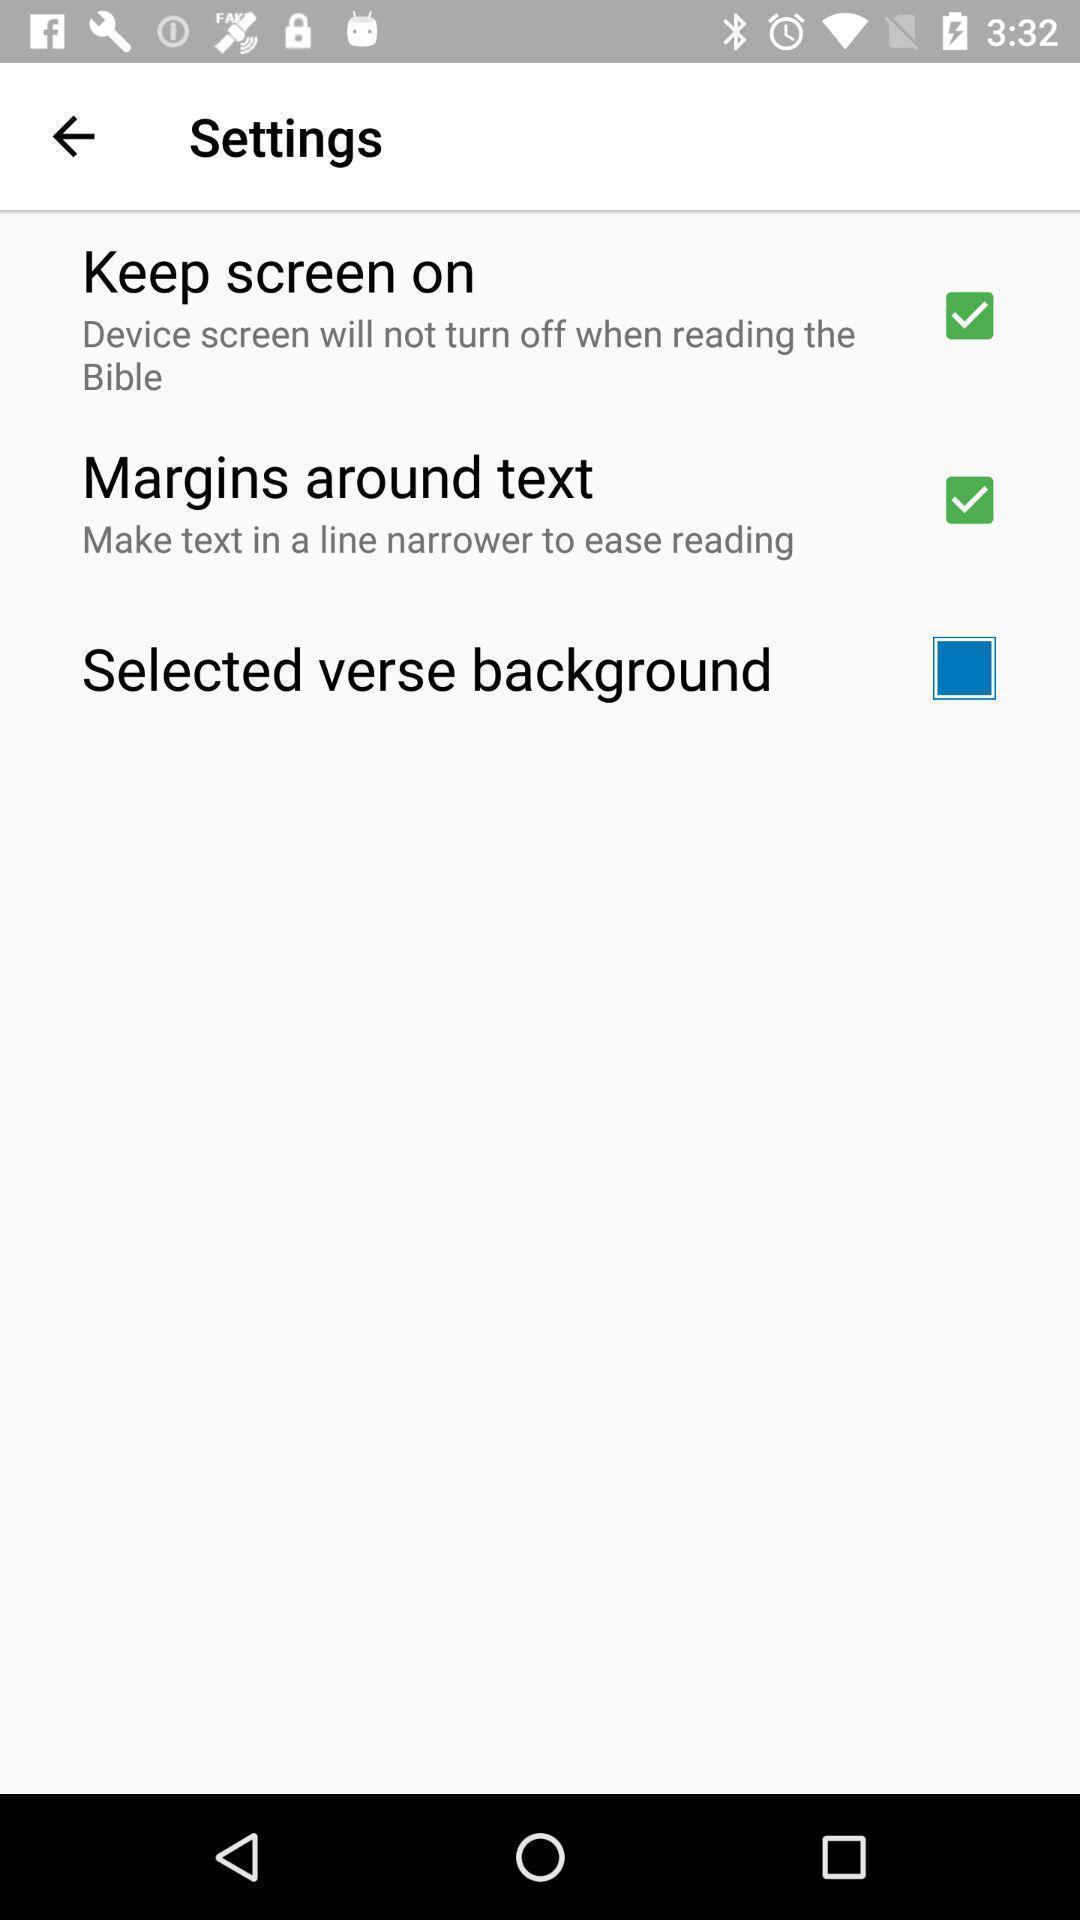Summarize the information in this screenshot. Settings in the mobile phone with different options. 